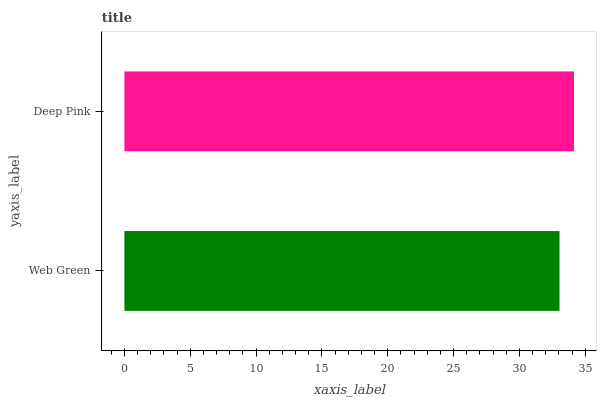Is Web Green the minimum?
Answer yes or no. Yes. Is Deep Pink the maximum?
Answer yes or no. Yes. Is Deep Pink the minimum?
Answer yes or no. No. Is Deep Pink greater than Web Green?
Answer yes or no. Yes. Is Web Green less than Deep Pink?
Answer yes or no. Yes. Is Web Green greater than Deep Pink?
Answer yes or no. No. Is Deep Pink less than Web Green?
Answer yes or no. No. Is Deep Pink the high median?
Answer yes or no. Yes. Is Web Green the low median?
Answer yes or no. Yes. Is Web Green the high median?
Answer yes or no. No. Is Deep Pink the low median?
Answer yes or no. No. 